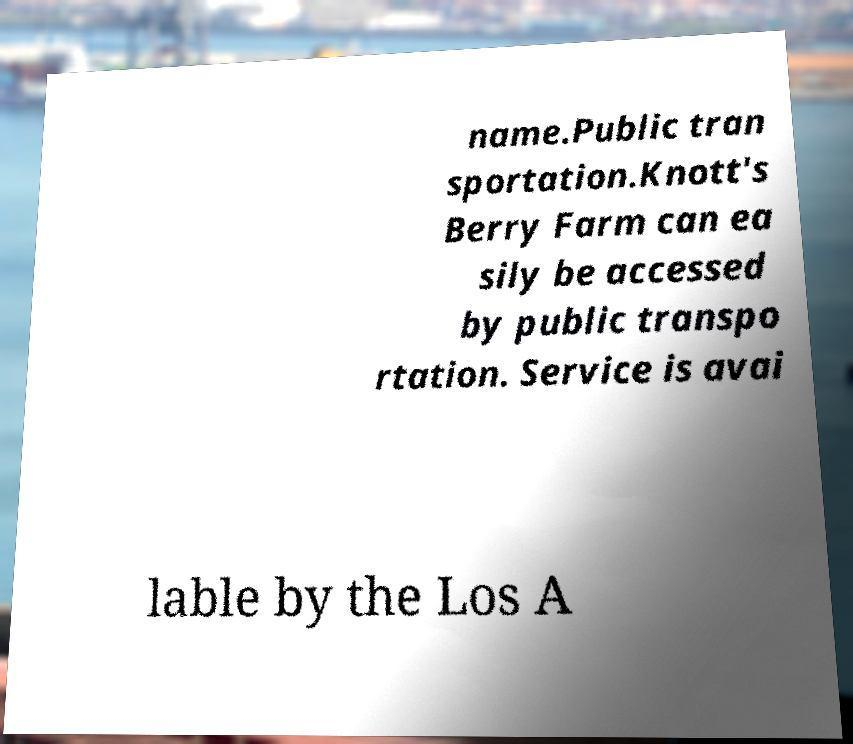Could you assist in decoding the text presented in this image and type it out clearly? name.Public tran sportation.Knott's Berry Farm can ea sily be accessed by public transpo rtation. Service is avai lable by the Los A 